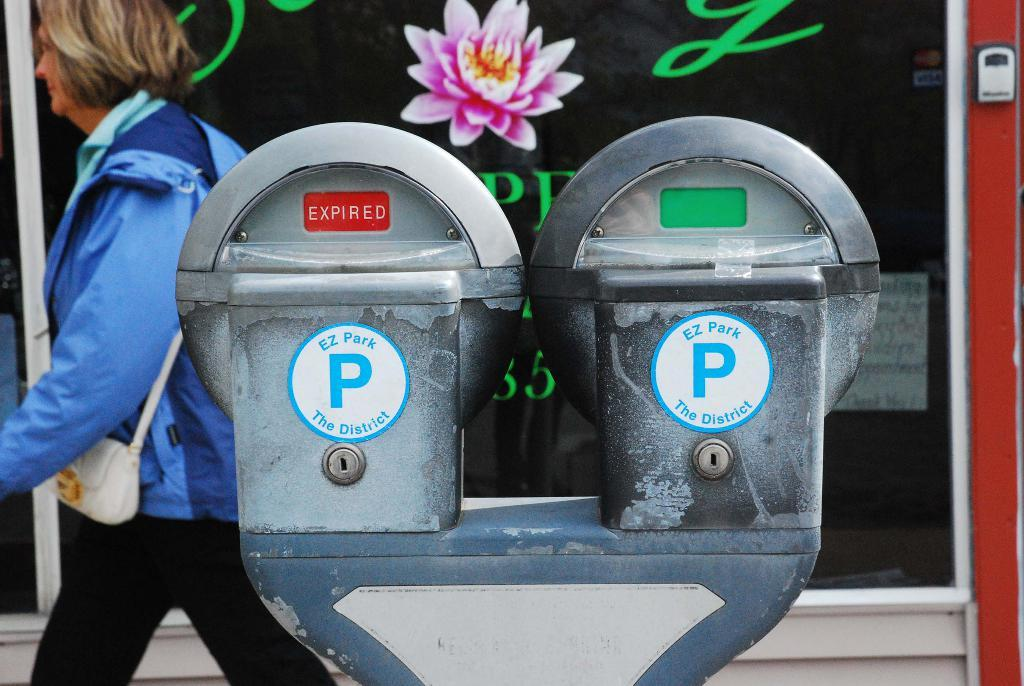<image>
Give a short and clear explanation of the subsequent image. woman walking past 2 ez park parking meters, one expired, one not 